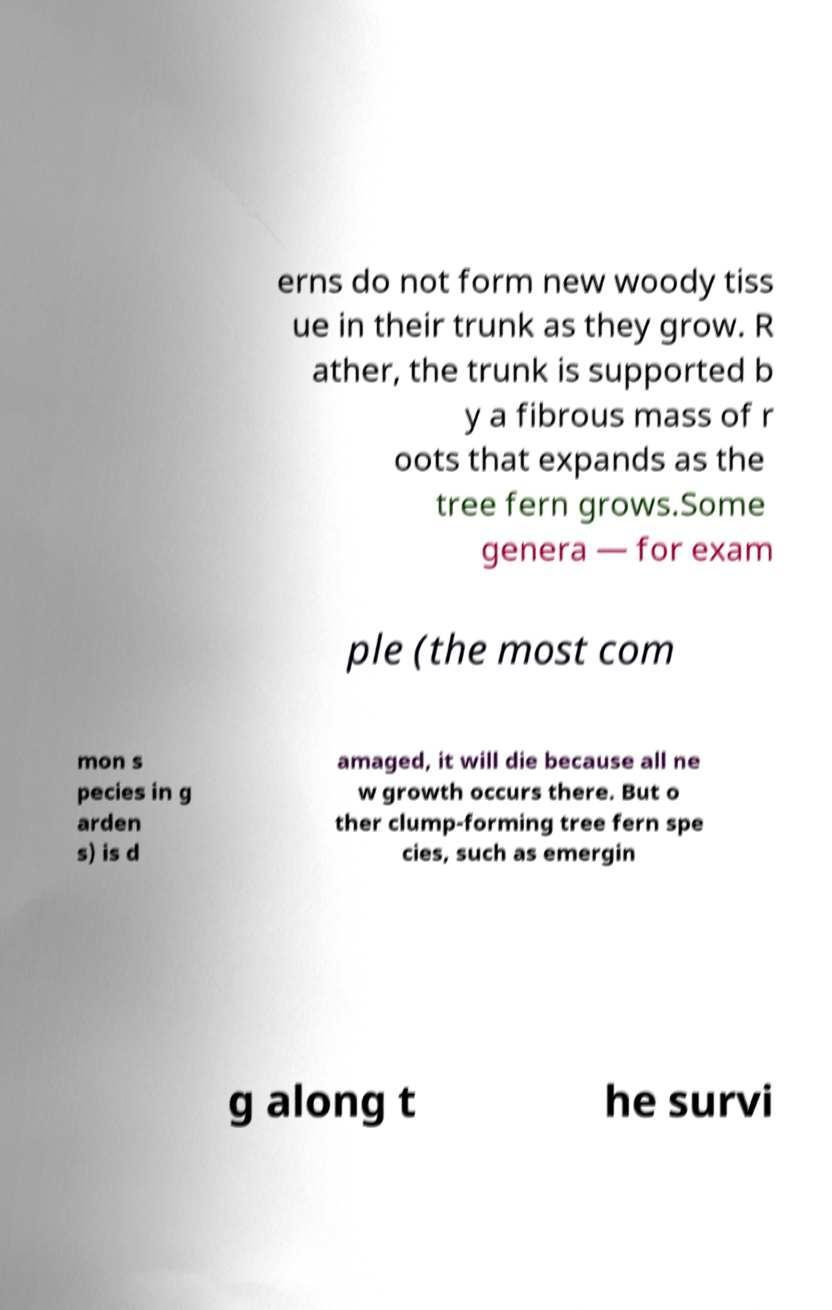Could you extract and type out the text from this image? erns do not form new woody tiss ue in their trunk as they grow. R ather, the trunk is supported b y a fibrous mass of r oots that expands as the tree fern grows.Some genera — for exam ple (the most com mon s pecies in g arden s) is d amaged, it will die because all ne w growth occurs there. But o ther clump-forming tree fern spe cies, such as emergin g along t he survi 